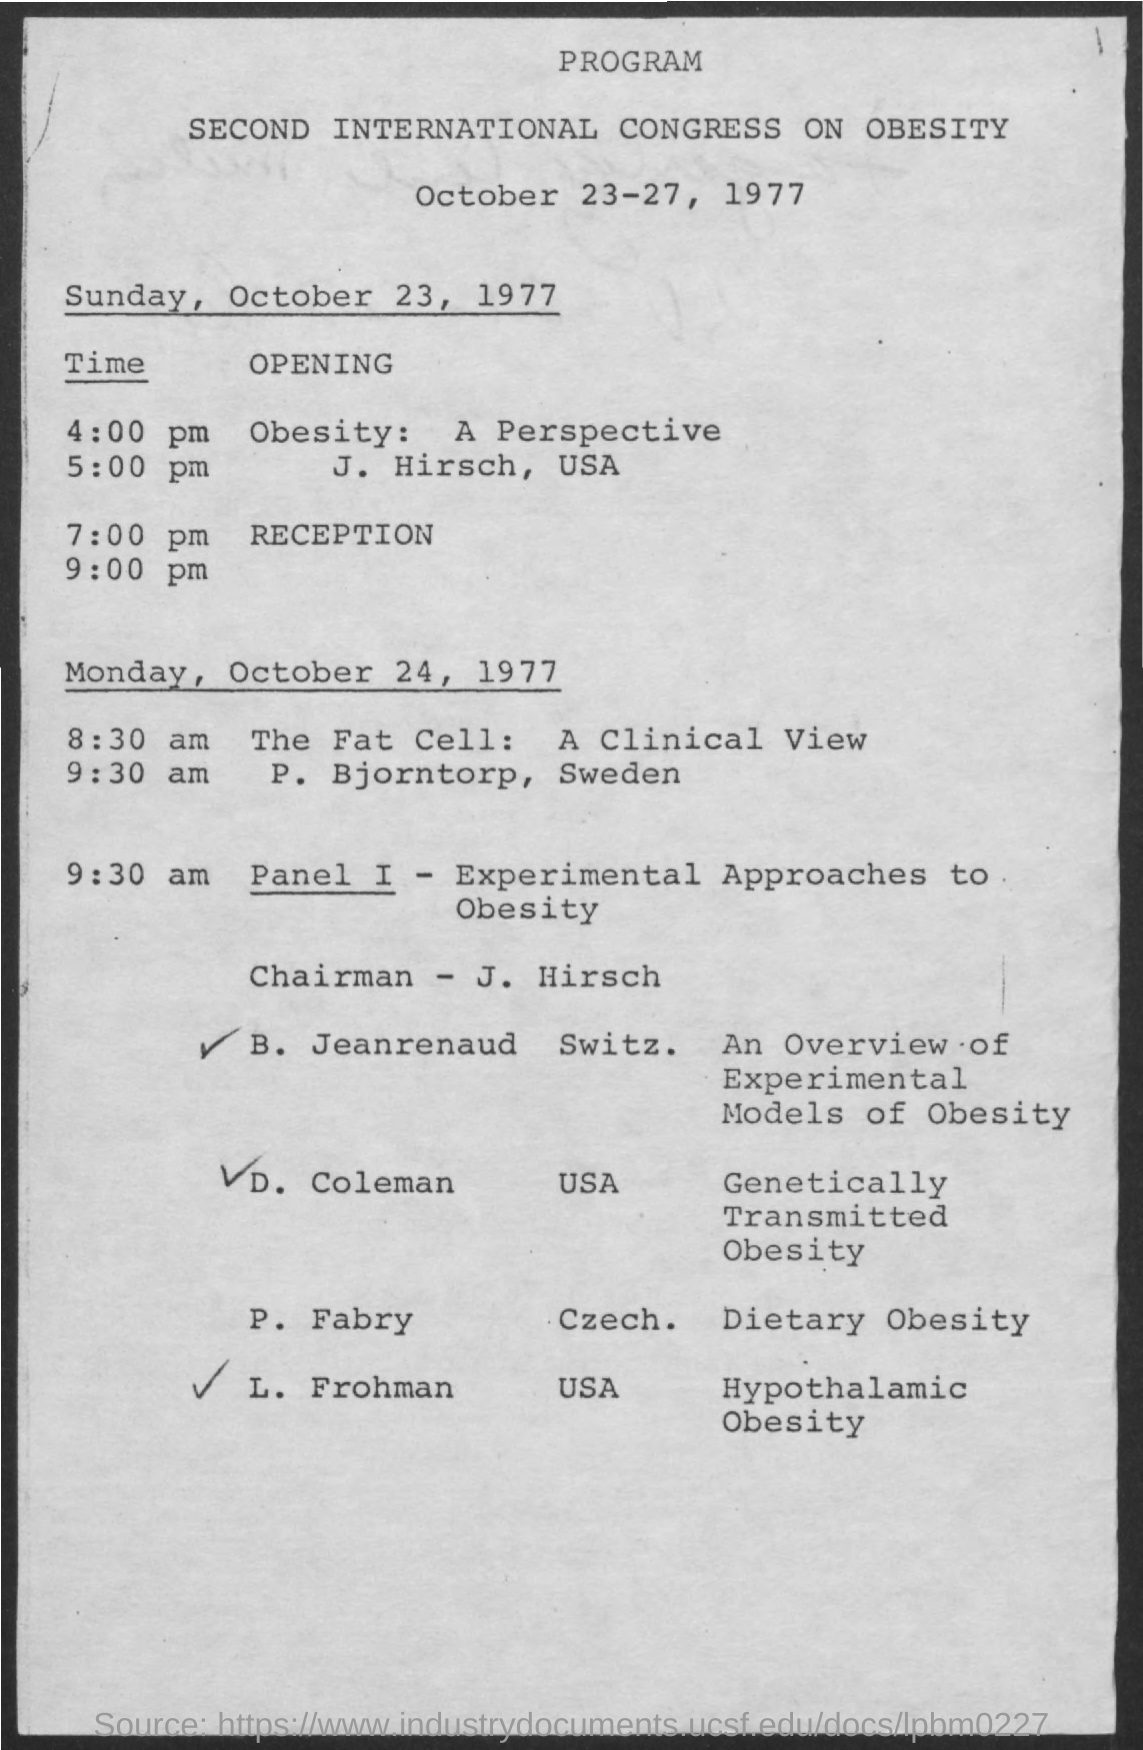What are the primary contributions of J. Hirsch in this event? J. Hirsch holds a significant role as the chairman for 'Panel I - Experimental Approaches to Obesity,' and he also shares his perspective on obesity during a session scheduled at 5:00 pm on October 23, 1977. 